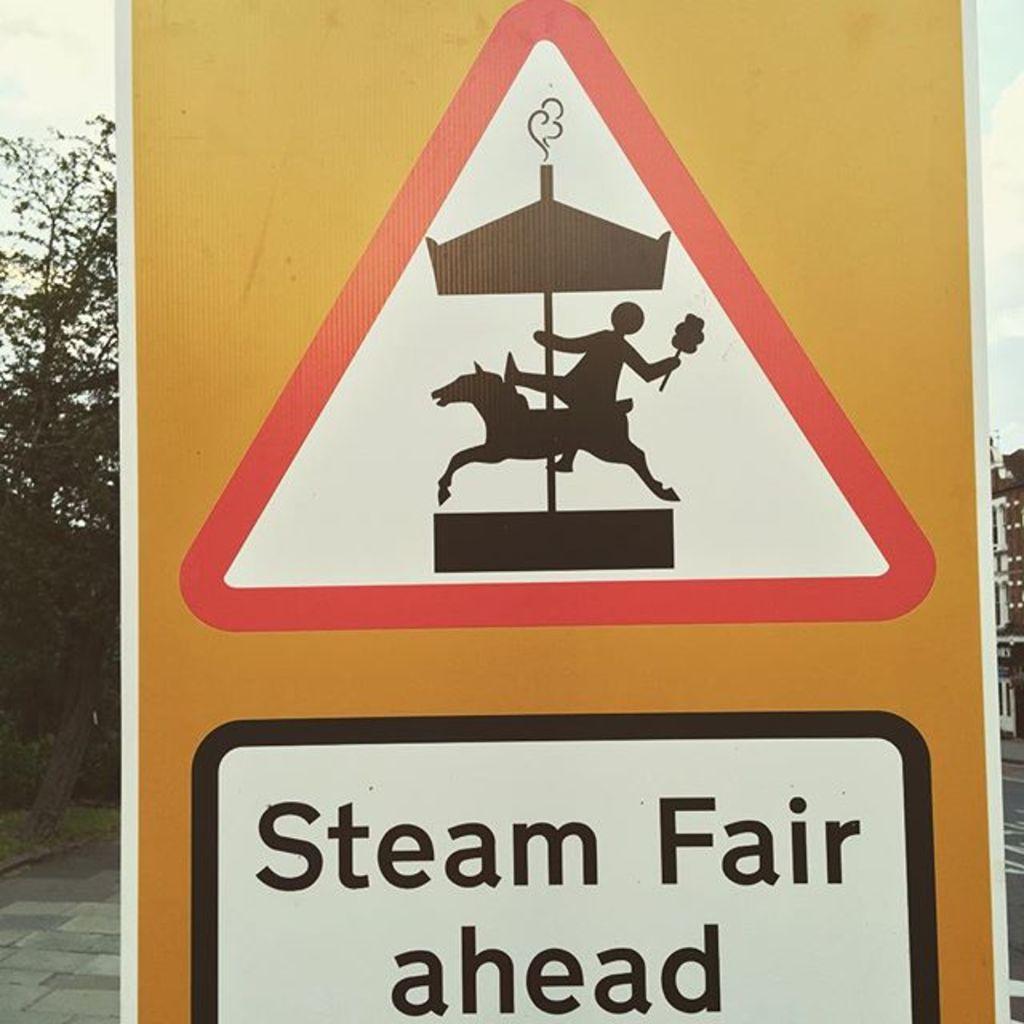What sort of fair is ahead?
Your answer should be compact. Steam. 